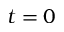Convert formula to latex. <formula><loc_0><loc_0><loc_500><loc_500>t = 0</formula> 